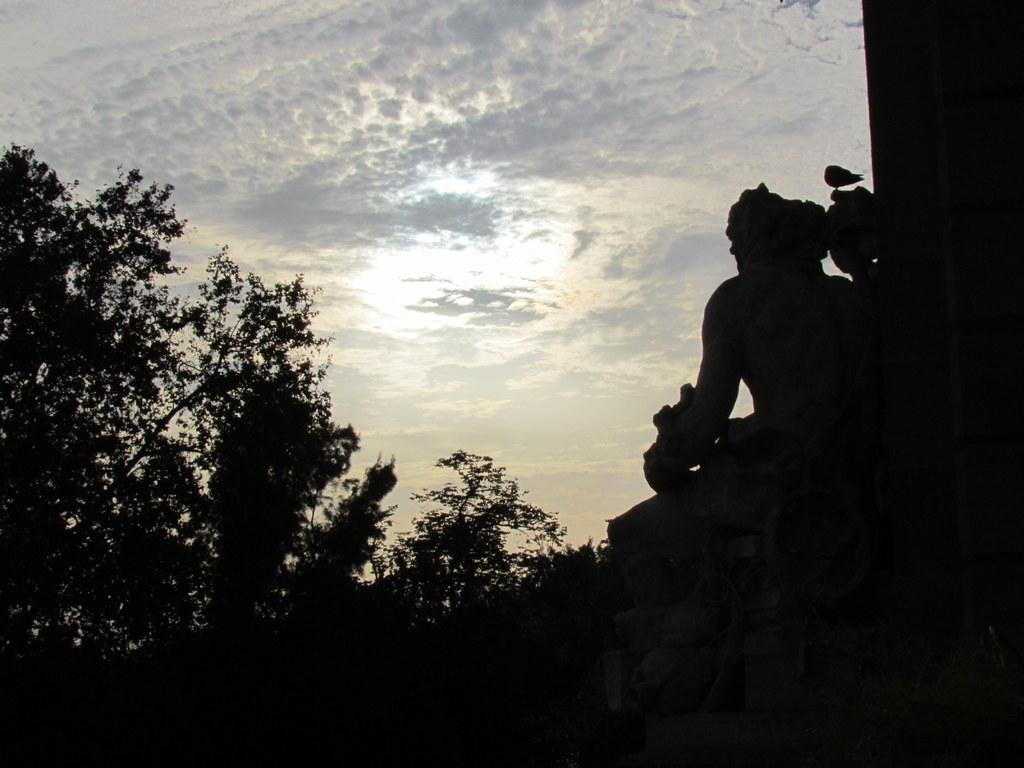How would you describe the sky in the image? The sky in the image appears gloomy. What type of vegetation can be seen at the bottom of the image? There are plants and trees visible at the bottom of the image. In what kind of setting are the plants and trees located? The plants and trees are in a dark setting. How many times does the water get shocked in the image? There is no water or shocking event depicted in the image. 